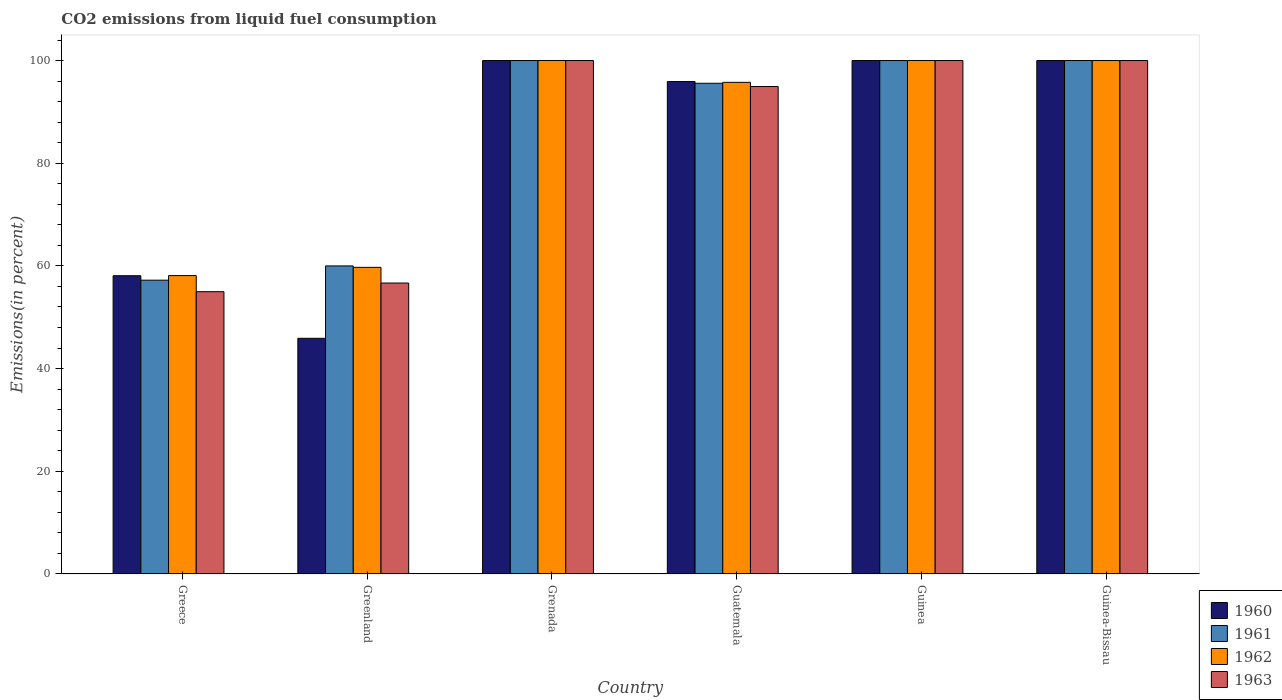How many different coloured bars are there?
Offer a terse response. 4. How many groups of bars are there?
Ensure brevity in your answer.  6. Are the number of bars per tick equal to the number of legend labels?
Provide a short and direct response. Yes. Are the number of bars on each tick of the X-axis equal?
Offer a terse response. Yes. How many bars are there on the 3rd tick from the left?
Provide a short and direct response. 4. How many bars are there on the 4th tick from the right?
Offer a terse response. 4. In how many cases, is the number of bars for a given country not equal to the number of legend labels?
Provide a succinct answer. 0. Across all countries, what is the minimum total CO2 emitted in 1963?
Make the answer very short. 54.98. In which country was the total CO2 emitted in 1962 maximum?
Offer a very short reply. Grenada. What is the total total CO2 emitted in 1963 in the graph?
Your response must be concise. 506.59. What is the average total CO2 emitted in 1963 per country?
Your response must be concise. 84.43. What is the difference between the total CO2 emitted of/in 1963 and total CO2 emitted of/in 1961 in Guinea-Bissau?
Ensure brevity in your answer.  0. In how many countries, is the total CO2 emitted in 1961 greater than 20 %?
Keep it short and to the point. 6. What is the ratio of the total CO2 emitted in 1960 in Guatemala to that in Guinea?
Provide a short and direct response. 0.96. What is the difference between the highest and the lowest total CO2 emitted in 1960?
Your answer should be very brief. 54.1. Is it the case that in every country, the sum of the total CO2 emitted in 1961 and total CO2 emitted in 1960 is greater than the sum of total CO2 emitted in 1963 and total CO2 emitted in 1962?
Provide a succinct answer. No. What does the 4th bar from the left in Grenada represents?
Give a very brief answer. 1963. What does the 1st bar from the right in Guatemala represents?
Offer a very short reply. 1963. Is it the case that in every country, the sum of the total CO2 emitted in 1960 and total CO2 emitted in 1962 is greater than the total CO2 emitted in 1961?
Your response must be concise. Yes. Does the graph contain any zero values?
Make the answer very short. No. Does the graph contain grids?
Ensure brevity in your answer.  No. Where does the legend appear in the graph?
Give a very brief answer. Bottom right. How many legend labels are there?
Make the answer very short. 4. How are the legend labels stacked?
Give a very brief answer. Vertical. What is the title of the graph?
Offer a very short reply. CO2 emissions from liquid fuel consumption. Does "1978" appear as one of the legend labels in the graph?
Keep it short and to the point. No. What is the label or title of the X-axis?
Make the answer very short. Country. What is the label or title of the Y-axis?
Your answer should be compact. Emissions(in percent). What is the Emissions(in percent) of 1960 in Greece?
Your response must be concise. 58.09. What is the Emissions(in percent) of 1961 in Greece?
Give a very brief answer. 57.22. What is the Emissions(in percent) in 1962 in Greece?
Make the answer very short. 58.12. What is the Emissions(in percent) of 1963 in Greece?
Your response must be concise. 54.98. What is the Emissions(in percent) of 1960 in Greenland?
Your response must be concise. 45.9. What is the Emissions(in percent) of 1961 in Greenland?
Provide a short and direct response. 60. What is the Emissions(in percent) in 1962 in Greenland?
Your answer should be very brief. 59.72. What is the Emissions(in percent) of 1963 in Greenland?
Offer a very short reply. 56.67. What is the Emissions(in percent) in 1963 in Grenada?
Your response must be concise. 100. What is the Emissions(in percent) in 1960 in Guatemala?
Give a very brief answer. 95.91. What is the Emissions(in percent) in 1961 in Guatemala?
Offer a terse response. 95.57. What is the Emissions(in percent) in 1962 in Guatemala?
Offer a terse response. 95.76. What is the Emissions(in percent) in 1963 in Guatemala?
Offer a very short reply. 94.94. What is the Emissions(in percent) of 1960 in Guinea?
Your answer should be compact. 100. What is the Emissions(in percent) of 1961 in Guinea?
Keep it short and to the point. 100. What is the Emissions(in percent) of 1960 in Guinea-Bissau?
Keep it short and to the point. 100. What is the Emissions(in percent) in 1963 in Guinea-Bissau?
Offer a very short reply. 100. Across all countries, what is the maximum Emissions(in percent) in 1960?
Ensure brevity in your answer.  100. Across all countries, what is the maximum Emissions(in percent) in 1961?
Keep it short and to the point. 100. Across all countries, what is the maximum Emissions(in percent) in 1963?
Your answer should be compact. 100. Across all countries, what is the minimum Emissions(in percent) in 1960?
Offer a very short reply. 45.9. Across all countries, what is the minimum Emissions(in percent) of 1961?
Provide a short and direct response. 57.22. Across all countries, what is the minimum Emissions(in percent) in 1962?
Your answer should be very brief. 58.12. Across all countries, what is the minimum Emissions(in percent) of 1963?
Your answer should be very brief. 54.98. What is the total Emissions(in percent) of 1960 in the graph?
Ensure brevity in your answer.  499.9. What is the total Emissions(in percent) of 1961 in the graph?
Your response must be concise. 512.8. What is the total Emissions(in percent) of 1962 in the graph?
Offer a terse response. 513.6. What is the total Emissions(in percent) in 1963 in the graph?
Give a very brief answer. 506.59. What is the difference between the Emissions(in percent) of 1960 in Greece and that in Greenland?
Make the answer very short. 12.19. What is the difference between the Emissions(in percent) in 1961 in Greece and that in Greenland?
Your answer should be very brief. -2.78. What is the difference between the Emissions(in percent) of 1962 in Greece and that in Greenland?
Provide a succinct answer. -1.61. What is the difference between the Emissions(in percent) of 1963 in Greece and that in Greenland?
Your answer should be very brief. -1.69. What is the difference between the Emissions(in percent) in 1960 in Greece and that in Grenada?
Provide a short and direct response. -41.91. What is the difference between the Emissions(in percent) of 1961 in Greece and that in Grenada?
Give a very brief answer. -42.78. What is the difference between the Emissions(in percent) of 1962 in Greece and that in Grenada?
Keep it short and to the point. -41.88. What is the difference between the Emissions(in percent) of 1963 in Greece and that in Grenada?
Make the answer very short. -45.02. What is the difference between the Emissions(in percent) of 1960 in Greece and that in Guatemala?
Give a very brief answer. -37.82. What is the difference between the Emissions(in percent) of 1961 in Greece and that in Guatemala?
Keep it short and to the point. -38.35. What is the difference between the Emissions(in percent) in 1962 in Greece and that in Guatemala?
Make the answer very short. -37.64. What is the difference between the Emissions(in percent) in 1963 in Greece and that in Guatemala?
Your answer should be compact. -39.96. What is the difference between the Emissions(in percent) in 1960 in Greece and that in Guinea?
Ensure brevity in your answer.  -41.91. What is the difference between the Emissions(in percent) of 1961 in Greece and that in Guinea?
Your answer should be very brief. -42.78. What is the difference between the Emissions(in percent) of 1962 in Greece and that in Guinea?
Your answer should be very brief. -41.88. What is the difference between the Emissions(in percent) in 1963 in Greece and that in Guinea?
Make the answer very short. -45.02. What is the difference between the Emissions(in percent) in 1960 in Greece and that in Guinea-Bissau?
Your answer should be very brief. -41.91. What is the difference between the Emissions(in percent) in 1961 in Greece and that in Guinea-Bissau?
Offer a very short reply. -42.78. What is the difference between the Emissions(in percent) in 1962 in Greece and that in Guinea-Bissau?
Provide a succinct answer. -41.88. What is the difference between the Emissions(in percent) in 1963 in Greece and that in Guinea-Bissau?
Your answer should be very brief. -45.02. What is the difference between the Emissions(in percent) of 1960 in Greenland and that in Grenada?
Offer a terse response. -54.1. What is the difference between the Emissions(in percent) of 1962 in Greenland and that in Grenada?
Offer a very short reply. -40.28. What is the difference between the Emissions(in percent) in 1963 in Greenland and that in Grenada?
Ensure brevity in your answer.  -43.33. What is the difference between the Emissions(in percent) of 1960 in Greenland and that in Guatemala?
Give a very brief answer. -50.01. What is the difference between the Emissions(in percent) of 1961 in Greenland and that in Guatemala?
Keep it short and to the point. -35.57. What is the difference between the Emissions(in percent) of 1962 in Greenland and that in Guatemala?
Offer a terse response. -36.03. What is the difference between the Emissions(in percent) of 1963 in Greenland and that in Guatemala?
Your response must be concise. -38.27. What is the difference between the Emissions(in percent) in 1960 in Greenland and that in Guinea?
Ensure brevity in your answer.  -54.1. What is the difference between the Emissions(in percent) of 1962 in Greenland and that in Guinea?
Your answer should be compact. -40.28. What is the difference between the Emissions(in percent) of 1963 in Greenland and that in Guinea?
Your response must be concise. -43.33. What is the difference between the Emissions(in percent) of 1960 in Greenland and that in Guinea-Bissau?
Provide a short and direct response. -54.1. What is the difference between the Emissions(in percent) in 1961 in Greenland and that in Guinea-Bissau?
Keep it short and to the point. -40. What is the difference between the Emissions(in percent) of 1962 in Greenland and that in Guinea-Bissau?
Make the answer very short. -40.28. What is the difference between the Emissions(in percent) of 1963 in Greenland and that in Guinea-Bissau?
Your response must be concise. -43.33. What is the difference between the Emissions(in percent) in 1960 in Grenada and that in Guatemala?
Ensure brevity in your answer.  4.09. What is the difference between the Emissions(in percent) of 1961 in Grenada and that in Guatemala?
Provide a succinct answer. 4.43. What is the difference between the Emissions(in percent) in 1962 in Grenada and that in Guatemala?
Keep it short and to the point. 4.24. What is the difference between the Emissions(in percent) of 1963 in Grenada and that in Guatemala?
Provide a succinct answer. 5.06. What is the difference between the Emissions(in percent) of 1963 in Grenada and that in Guinea?
Make the answer very short. 0. What is the difference between the Emissions(in percent) in 1960 in Grenada and that in Guinea-Bissau?
Your response must be concise. 0. What is the difference between the Emissions(in percent) of 1961 in Grenada and that in Guinea-Bissau?
Offer a terse response. 0. What is the difference between the Emissions(in percent) of 1963 in Grenada and that in Guinea-Bissau?
Provide a succinct answer. 0. What is the difference between the Emissions(in percent) of 1960 in Guatemala and that in Guinea?
Your answer should be very brief. -4.09. What is the difference between the Emissions(in percent) of 1961 in Guatemala and that in Guinea?
Provide a short and direct response. -4.43. What is the difference between the Emissions(in percent) in 1962 in Guatemala and that in Guinea?
Your answer should be very brief. -4.24. What is the difference between the Emissions(in percent) of 1963 in Guatemala and that in Guinea?
Give a very brief answer. -5.06. What is the difference between the Emissions(in percent) in 1960 in Guatemala and that in Guinea-Bissau?
Make the answer very short. -4.09. What is the difference between the Emissions(in percent) in 1961 in Guatemala and that in Guinea-Bissau?
Make the answer very short. -4.43. What is the difference between the Emissions(in percent) in 1962 in Guatemala and that in Guinea-Bissau?
Your answer should be very brief. -4.24. What is the difference between the Emissions(in percent) of 1963 in Guatemala and that in Guinea-Bissau?
Keep it short and to the point. -5.06. What is the difference between the Emissions(in percent) in 1960 in Greece and the Emissions(in percent) in 1961 in Greenland?
Your answer should be very brief. -1.91. What is the difference between the Emissions(in percent) in 1960 in Greece and the Emissions(in percent) in 1962 in Greenland?
Provide a succinct answer. -1.63. What is the difference between the Emissions(in percent) of 1960 in Greece and the Emissions(in percent) of 1963 in Greenland?
Give a very brief answer. 1.42. What is the difference between the Emissions(in percent) in 1961 in Greece and the Emissions(in percent) in 1962 in Greenland?
Your answer should be compact. -2.5. What is the difference between the Emissions(in percent) of 1961 in Greece and the Emissions(in percent) of 1963 in Greenland?
Your answer should be very brief. 0.56. What is the difference between the Emissions(in percent) of 1962 in Greece and the Emissions(in percent) of 1963 in Greenland?
Give a very brief answer. 1.45. What is the difference between the Emissions(in percent) of 1960 in Greece and the Emissions(in percent) of 1961 in Grenada?
Your answer should be compact. -41.91. What is the difference between the Emissions(in percent) of 1960 in Greece and the Emissions(in percent) of 1962 in Grenada?
Offer a terse response. -41.91. What is the difference between the Emissions(in percent) in 1960 in Greece and the Emissions(in percent) in 1963 in Grenada?
Give a very brief answer. -41.91. What is the difference between the Emissions(in percent) of 1961 in Greece and the Emissions(in percent) of 1962 in Grenada?
Your answer should be very brief. -42.78. What is the difference between the Emissions(in percent) in 1961 in Greece and the Emissions(in percent) in 1963 in Grenada?
Ensure brevity in your answer.  -42.78. What is the difference between the Emissions(in percent) of 1962 in Greece and the Emissions(in percent) of 1963 in Grenada?
Give a very brief answer. -41.88. What is the difference between the Emissions(in percent) in 1960 in Greece and the Emissions(in percent) in 1961 in Guatemala?
Your answer should be compact. -37.48. What is the difference between the Emissions(in percent) of 1960 in Greece and the Emissions(in percent) of 1962 in Guatemala?
Give a very brief answer. -37.67. What is the difference between the Emissions(in percent) of 1960 in Greece and the Emissions(in percent) of 1963 in Guatemala?
Your response must be concise. -36.85. What is the difference between the Emissions(in percent) in 1961 in Greece and the Emissions(in percent) in 1962 in Guatemala?
Your answer should be compact. -38.53. What is the difference between the Emissions(in percent) of 1961 in Greece and the Emissions(in percent) of 1963 in Guatemala?
Keep it short and to the point. -37.72. What is the difference between the Emissions(in percent) of 1962 in Greece and the Emissions(in percent) of 1963 in Guatemala?
Your response must be concise. -36.82. What is the difference between the Emissions(in percent) of 1960 in Greece and the Emissions(in percent) of 1961 in Guinea?
Your response must be concise. -41.91. What is the difference between the Emissions(in percent) of 1960 in Greece and the Emissions(in percent) of 1962 in Guinea?
Your response must be concise. -41.91. What is the difference between the Emissions(in percent) of 1960 in Greece and the Emissions(in percent) of 1963 in Guinea?
Provide a succinct answer. -41.91. What is the difference between the Emissions(in percent) in 1961 in Greece and the Emissions(in percent) in 1962 in Guinea?
Your response must be concise. -42.78. What is the difference between the Emissions(in percent) in 1961 in Greece and the Emissions(in percent) in 1963 in Guinea?
Make the answer very short. -42.78. What is the difference between the Emissions(in percent) of 1962 in Greece and the Emissions(in percent) of 1963 in Guinea?
Ensure brevity in your answer.  -41.88. What is the difference between the Emissions(in percent) of 1960 in Greece and the Emissions(in percent) of 1961 in Guinea-Bissau?
Keep it short and to the point. -41.91. What is the difference between the Emissions(in percent) in 1960 in Greece and the Emissions(in percent) in 1962 in Guinea-Bissau?
Keep it short and to the point. -41.91. What is the difference between the Emissions(in percent) in 1960 in Greece and the Emissions(in percent) in 1963 in Guinea-Bissau?
Your answer should be very brief. -41.91. What is the difference between the Emissions(in percent) of 1961 in Greece and the Emissions(in percent) of 1962 in Guinea-Bissau?
Make the answer very short. -42.78. What is the difference between the Emissions(in percent) in 1961 in Greece and the Emissions(in percent) in 1963 in Guinea-Bissau?
Provide a short and direct response. -42.78. What is the difference between the Emissions(in percent) in 1962 in Greece and the Emissions(in percent) in 1963 in Guinea-Bissau?
Provide a succinct answer. -41.88. What is the difference between the Emissions(in percent) in 1960 in Greenland and the Emissions(in percent) in 1961 in Grenada?
Make the answer very short. -54.1. What is the difference between the Emissions(in percent) of 1960 in Greenland and the Emissions(in percent) of 1962 in Grenada?
Ensure brevity in your answer.  -54.1. What is the difference between the Emissions(in percent) in 1960 in Greenland and the Emissions(in percent) in 1963 in Grenada?
Keep it short and to the point. -54.1. What is the difference between the Emissions(in percent) of 1961 in Greenland and the Emissions(in percent) of 1962 in Grenada?
Keep it short and to the point. -40. What is the difference between the Emissions(in percent) in 1962 in Greenland and the Emissions(in percent) in 1963 in Grenada?
Give a very brief answer. -40.28. What is the difference between the Emissions(in percent) in 1960 in Greenland and the Emissions(in percent) in 1961 in Guatemala?
Ensure brevity in your answer.  -49.67. What is the difference between the Emissions(in percent) in 1960 in Greenland and the Emissions(in percent) in 1962 in Guatemala?
Provide a succinct answer. -49.85. What is the difference between the Emissions(in percent) of 1960 in Greenland and the Emissions(in percent) of 1963 in Guatemala?
Make the answer very short. -49.04. What is the difference between the Emissions(in percent) of 1961 in Greenland and the Emissions(in percent) of 1962 in Guatemala?
Make the answer very short. -35.76. What is the difference between the Emissions(in percent) of 1961 in Greenland and the Emissions(in percent) of 1963 in Guatemala?
Your answer should be compact. -34.94. What is the difference between the Emissions(in percent) in 1962 in Greenland and the Emissions(in percent) in 1963 in Guatemala?
Make the answer very short. -35.22. What is the difference between the Emissions(in percent) of 1960 in Greenland and the Emissions(in percent) of 1961 in Guinea?
Provide a short and direct response. -54.1. What is the difference between the Emissions(in percent) of 1960 in Greenland and the Emissions(in percent) of 1962 in Guinea?
Offer a very short reply. -54.1. What is the difference between the Emissions(in percent) in 1960 in Greenland and the Emissions(in percent) in 1963 in Guinea?
Offer a very short reply. -54.1. What is the difference between the Emissions(in percent) in 1961 in Greenland and the Emissions(in percent) in 1963 in Guinea?
Offer a terse response. -40. What is the difference between the Emissions(in percent) in 1962 in Greenland and the Emissions(in percent) in 1963 in Guinea?
Give a very brief answer. -40.28. What is the difference between the Emissions(in percent) in 1960 in Greenland and the Emissions(in percent) in 1961 in Guinea-Bissau?
Ensure brevity in your answer.  -54.1. What is the difference between the Emissions(in percent) in 1960 in Greenland and the Emissions(in percent) in 1962 in Guinea-Bissau?
Your answer should be very brief. -54.1. What is the difference between the Emissions(in percent) of 1960 in Greenland and the Emissions(in percent) of 1963 in Guinea-Bissau?
Make the answer very short. -54.1. What is the difference between the Emissions(in percent) in 1962 in Greenland and the Emissions(in percent) in 1963 in Guinea-Bissau?
Provide a short and direct response. -40.28. What is the difference between the Emissions(in percent) in 1960 in Grenada and the Emissions(in percent) in 1961 in Guatemala?
Offer a terse response. 4.43. What is the difference between the Emissions(in percent) of 1960 in Grenada and the Emissions(in percent) of 1962 in Guatemala?
Give a very brief answer. 4.24. What is the difference between the Emissions(in percent) in 1960 in Grenada and the Emissions(in percent) in 1963 in Guatemala?
Keep it short and to the point. 5.06. What is the difference between the Emissions(in percent) of 1961 in Grenada and the Emissions(in percent) of 1962 in Guatemala?
Offer a terse response. 4.24. What is the difference between the Emissions(in percent) of 1961 in Grenada and the Emissions(in percent) of 1963 in Guatemala?
Your answer should be very brief. 5.06. What is the difference between the Emissions(in percent) in 1962 in Grenada and the Emissions(in percent) in 1963 in Guatemala?
Your response must be concise. 5.06. What is the difference between the Emissions(in percent) in 1960 in Grenada and the Emissions(in percent) in 1961 in Guinea?
Give a very brief answer. 0. What is the difference between the Emissions(in percent) of 1960 in Grenada and the Emissions(in percent) of 1962 in Guinea?
Your answer should be very brief. 0. What is the difference between the Emissions(in percent) of 1960 in Grenada and the Emissions(in percent) of 1961 in Guinea-Bissau?
Provide a short and direct response. 0. What is the difference between the Emissions(in percent) of 1961 in Grenada and the Emissions(in percent) of 1963 in Guinea-Bissau?
Give a very brief answer. 0. What is the difference between the Emissions(in percent) in 1962 in Grenada and the Emissions(in percent) in 1963 in Guinea-Bissau?
Give a very brief answer. 0. What is the difference between the Emissions(in percent) of 1960 in Guatemala and the Emissions(in percent) of 1961 in Guinea?
Provide a short and direct response. -4.09. What is the difference between the Emissions(in percent) in 1960 in Guatemala and the Emissions(in percent) in 1962 in Guinea?
Offer a terse response. -4.09. What is the difference between the Emissions(in percent) in 1960 in Guatemala and the Emissions(in percent) in 1963 in Guinea?
Give a very brief answer. -4.09. What is the difference between the Emissions(in percent) of 1961 in Guatemala and the Emissions(in percent) of 1962 in Guinea?
Your response must be concise. -4.43. What is the difference between the Emissions(in percent) of 1961 in Guatemala and the Emissions(in percent) of 1963 in Guinea?
Your answer should be compact. -4.43. What is the difference between the Emissions(in percent) in 1962 in Guatemala and the Emissions(in percent) in 1963 in Guinea?
Provide a short and direct response. -4.24. What is the difference between the Emissions(in percent) of 1960 in Guatemala and the Emissions(in percent) of 1961 in Guinea-Bissau?
Make the answer very short. -4.09. What is the difference between the Emissions(in percent) of 1960 in Guatemala and the Emissions(in percent) of 1962 in Guinea-Bissau?
Provide a short and direct response. -4.09. What is the difference between the Emissions(in percent) of 1960 in Guatemala and the Emissions(in percent) of 1963 in Guinea-Bissau?
Ensure brevity in your answer.  -4.09. What is the difference between the Emissions(in percent) in 1961 in Guatemala and the Emissions(in percent) in 1962 in Guinea-Bissau?
Offer a very short reply. -4.43. What is the difference between the Emissions(in percent) in 1961 in Guatemala and the Emissions(in percent) in 1963 in Guinea-Bissau?
Your answer should be compact. -4.43. What is the difference between the Emissions(in percent) of 1962 in Guatemala and the Emissions(in percent) of 1963 in Guinea-Bissau?
Offer a very short reply. -4.24. What is the difference between the Emissions(in percent) in 1960 in Guinea and the Emissions(in percent) in 1962 in Guinea-Bissau?
Your response must be concise. 0. What is the difference between the Emissions(in percent) of 1961 in Guinea and the Emissions(in percent) of 1962 in Guinea-Bissau?
Provide a short and direct response. 0. What is the difference between the Emissions(in percent) in 1961 in Guinea and the Emissions(in percent) in 1963 in Guinea-Bissau?
Make the answer very short. 0. What is the average Emissions(in percent) in 1960 per country?
Your answer should be very brief. 83.32. What is the average Emissions(in percent) of 1961 per country?
Make the answer very short. 85.47. What is the average Emissions(in percent) in 1962 per country?
Your response must be concise. 85.6. What is the average Emissions(in percent) in 1963 per country?
Your response must be concise. 84.43. What is the difference between the Emissions(in percent) in 1960 and Emissions(in percent) in 1961 in Greece?
Make the answer very short. 0.87. What is the difference between the Emissions(in percent) in 1960 and Emissions(in percent) in 1962 in Greece?
Your answer should be very brief. -0.03. What is the difference between the Emissions(in percent) in 1960 and Emissions(in percent) in 1963 in Greece?
Keep it short and to the point. 3.11. What is the difference between the Emissions(in percent) of 1961 and Emissions(in percent) of 1962 in Greece?
Give a very brief answer. -0.89. What is the difference between the Emissions(in percent) in 1961 and Emissions(in percent) in 1963 in Greece?
Provide a succinct answer. 2.24. What is the difference between the Emissions(in percent) of 1962 and Emissions(in percent) of 1963 in Greece?
Offer a very short reply. 3.14. What is the difference between the Emissions(in percent) of 1960 and Emissions(in percent) of 1961 in Greenland?
Your answer should be very brief. -14.1. What is the difference between the Emissions(in percent) of 1960 and Emissions(in percent) of 1962 in Greenland?
Provide a succinct answer. -13.82. What is the difference between the Emissions(in percent) of 1960 and Emissions(in percent) of 1963 in Greenland?
Give a very brief answer. -10.77. What is the difference between the Emissions(in percent) in 1961 and Emissions(in percent) in 1962 in Greenland?
Your response must be concise. 0.28. What is the difference between the Emissions(in percent) of 1962 and Emissions(in percent) of 1963 in Greenland?
Provide a short and direct response. 3.06. What is the difference between the Emissions(in percent) in 1961 and Emissions(in percent) in 1962 in Grenada?
Your response must be concise. 0. What is the difference between the Emissions(in percent) in 1960 and Emissions(in percent) in 1961 in Guatemala?
Offer a very short reply. 0.34. What is the difference between the Emissions(in percent) in 1960 and Emissions(in percent) in 1962 in Guatemala?
Make the answer very short. 0.16. What is the difference between the Emissions(in percent) of 1961 and Emissions(in percent) of 1962 in Guatemala?
Provide a short and direct response. -0.18. What is the difference between the Emissions(in percent) of 1961 and Emissions(in percent) of 1963 in Guatemala?
Your answer should be very brief. 0.63. What is the difference between the Emissions(in percent) of 1962 and Emissions(in percent) of 1963 in Guatemala?
Your answer should be very brief. 0.82. What is the difference between the Emissions(in percent) of 1960 and Emissions(in percent) of 1963 in Guinea?
Your answer should be very brief. 0. What is the difference between the Emissions(in percent) of 1960 and Emissions(in percent) of 1963 in Guinea-Bissau?
Give a very brief answer. 0. What is the difference between the Emissions(in percent) of 1961 and Emissions(in percent) of 1962 in Guinea-Bissau?
Give a very brief answer. 0. What is the difference between the Emissions(in percent) of 1961 and Emissions(in percent) of 1963 in Guinea-Bissau?
Your response must be concise. 0. What is the difference between the Emissions(in percent) of 1962 and Emissions(in percent) of 1963 in Guinea-Bissau?
Your response must be concise. 0. What is the ratio of the Emissions(in percent) of 1960 in Greece to that in Greenland?
Offer a very short reply. 1.27. What is the ratio of the Emissions(in percent) of 1961 in Greece to that in Greenland?
Ensure brevity in your answer.  0.95. What is the ratio of the Emissions(in percent) of 1962 in Greece to that in Greenland?
Your answer should be compact. 0.97. What is the ratio of the Emissions(in percent) of 1963 in Greece to that in Greenland?
Provide a short and direct response. 0.97. What is the ratio of the Emissions(in percent) in 1960 in Greece to that in Grenada?
Offer a terse response. 0.58. What is the ratio of the Emissions(in percent) in 1961 in Greece to that in Grenada?
Offer a terse response. 0.57. What is the ratio of the Emissions(in percent) of 1962 in Greece to that in Grenada?
Give a very brief answer. 0.58. What is the ratio of the Emissions(in percent) of 1963 in Greece to that in Grenada?
Your answer should be compact. 0.55. What is the ratio of the Emissions(in percent) of 1960 in Greece to that in Guatemala?
Ensure brevity in your answer.  0.61. What is the ratio of the Emissions(in percent) in 1961 in Greece to that in Guatemala?
Your response must be concise. 0.6. What is the ratio of the Emissions(in percent) of 1962 in Greece to that in Guatemala?
Offer a terse response. 0.61. What is the ratio of the Emissions(in percent) in 1963 in Greece to that in Guatemala?
Provide a succinct answer. 0.58. What is the ratio of the Emissions(in percent) of 1960 in Greece to that in Guinea?
Offer a terse response. 0.58. What is the ratio of the Emissions(in percent) in 1961 in Greece to that in Guinea?
Provide a succinct answer. 0.57. What is the ratio of the Emissions(in percent) of 1962 in Greece to that in Guinea?
Make the answer very short. 0.58. What is the ratio of the Emissions(in percent) of 1963 in Greece to that in Guinea?
Your answer should be compact. 0.55. What is the ratio of the Emissions(in percent) in 1960 in Greece to that in Guinea-Bissau?
Make the answer very short. 0.58. What is the ratio of the Emissions(in percent) of 1961 in Greece to that in Guinea-Bissau?
Provide a short and direct response. 0.57. What is the ratio of the Emissions(in percent) of 1962 in Greece to that in Guinea-Bissau?
Keep it short and to the point. 0.58. What is the ratio of the Emissions(in percent) of 1963 in Greece to that in Guinea-Bissau?
Provide a short and direct response. 0.55. What is the ratio of the Emissions(in percent) in 1960 in Greenland to that in Grenada?
Make the answer very short. 0.46. What is the ratio of the Emissions(in percent) of 1961 in Greenland to that in Grenada?
Make the answer very short. 0.6. What is the ratio of the Emissions(in percent) of 1962 in Greenland to that in Grenada?
Make the answer very short. 0.6. What is the ratio of the Emissions(in percent) in 1963 in Greenland to that in Grenada?
Offer a terse response. 0.57. What is the ratio of the Emissions(in percent) in 1960 in Greenland to that in Guatemala?
Your response must be concise. 0.48. What is the ratio of the Emissions(in percent) in 1961 in Greenland to that in Guatemala?
Offer a terse response. 0.63. What is the ratio of the Emissions(in percent) in 1962 in Greenland to that in Guatemala?
Make the answer very short. 0.62. What is the ratio of the Emissions(in percent) of 1963 in Greenland to that in Guatemala?
Give a very brief answer. 0.6. What is the ratio of the Emissions(in percent) in 1960 in Greenland to that in Guinea?
Offer a terse response. 0.46. What is the ratio of the Emissions(in percent) in 1962 in Greenland to that in Guinea?
Make the answer very short. 0.6. What is the ratio of the Emissions(in percent) of 1963 in Greenland to that in Guinea?
Provide a short and direct response. 0.57. What is the ratio of the Emissions(in percent) in 1960 in Greenland to that in Guinea-Bissau?
Make the answer very short. 0.46. What is the ratio of the Emissions(in percent) of 1962 in Greenland to that in Guinea-Bissau?
Make the answer very short. 0.6. What is the ratio of the Emissions(in percent) of 1963 in Greenland to that in Guinea-Bissau?
Offer a terse response. 0.57. What is the ratio of the Emissions(in percent) of 1960 in Grenada to that in Guatemala?
Give a very brief answer. 1.04. What is the ratio of the Emissions(in percent) in 1961 in Grenada to that in Guatemala?
Your answer should be very brief. 1.05. What is the ratio of the Emissions(in percent) of 1962 in Grenada to that in Guatemala?
Offer a terse response. 1.04. What is the ratio of the Emissions(in percent) in 1963 in Grenada to that in Guatemala?
Keep it short and to the point. 1.05. What is the ratio of the Emissions(in percent) of 1961 in Grenada to that in Guinea?
Make the answer very short. 1. What is the ratio of the Emissions(in percent) in 1962 in Grenada to that in Guinea?
Keep it short and to the point. 1. What is the ratio of the Emissions(in percent) of 1960 in Grenada to that in Guinea-Bissau?
Your answer should be compact. 1. What is the ratio of the Emissions(in percent) in 1960 in Guatemala to that in Guinea?
Keep it short and to the point. 0.96. What is the ratio of the Emissions(in percent) of 1961 in Guatemala to that in Guinea?
Offer a terse response. 0.96. What is the ratio of the Emissions(in percent) of 1962 in Guatemala to that in Guinea?
Provide a succinct answer. 0.96. What is the ratio of the Emissions(in percent) of 1963 in Guatemala to that in Guinea?
Give a very brief answer. 0.95. What is the ratio of the Emissions(in percent) in 1960 in Guatemala to that in Guinea-Bissau?
Keep it short and to the point. 0.96. What is the ratio of the Emissions(in percent) of 1961 in Guatemala to that in Guinea-Bissau?
Your response must be concise. 0.96. What is the ratio of the Emissions(in percent) of 1962 in Guatemala to that in Guinea-Bissau?
Keep it short and to the point. 0.96. What is the ratio of the Emissions(in percent) in 1963 in Guatemala to that in Guinea-Bissau?
Your answer should be compact. 0.95. What is the ratio of the Emissions(in percent) in 1960 in Guinea to that in Guinea-Bissau?
Provide a short and direct response. 1. What is the ratio of the Emissions(in percent) in 1961 in Guinea to that in Guinea-Bissau?
Give a very brief answer. 1. What is the ratio of the Emissions(in percent) in 1962 in Guinea to that in Guinea-Bissau?
Offer a terse response. 1. What is the difference between the highest and the second highest Emissions(in percent) of 1963?
Your answer should be very brief. 0. What is the difference between the highest and the lowest Emissions(in percent) of 1960?
Your response must be concise. 54.1. What is the difference between the highest and the lowest Emissions(in percent) of 1961?
Your answer should be very brief. 42.78. What is the difference between the highest and the lowest Emissions(in percent) in 1962?
Your answer should be compact. 41.88. What is the difference between the highest and the lowest Emissions(in percent) in 1963?
Ensure brevity in your answer.  45.02. 